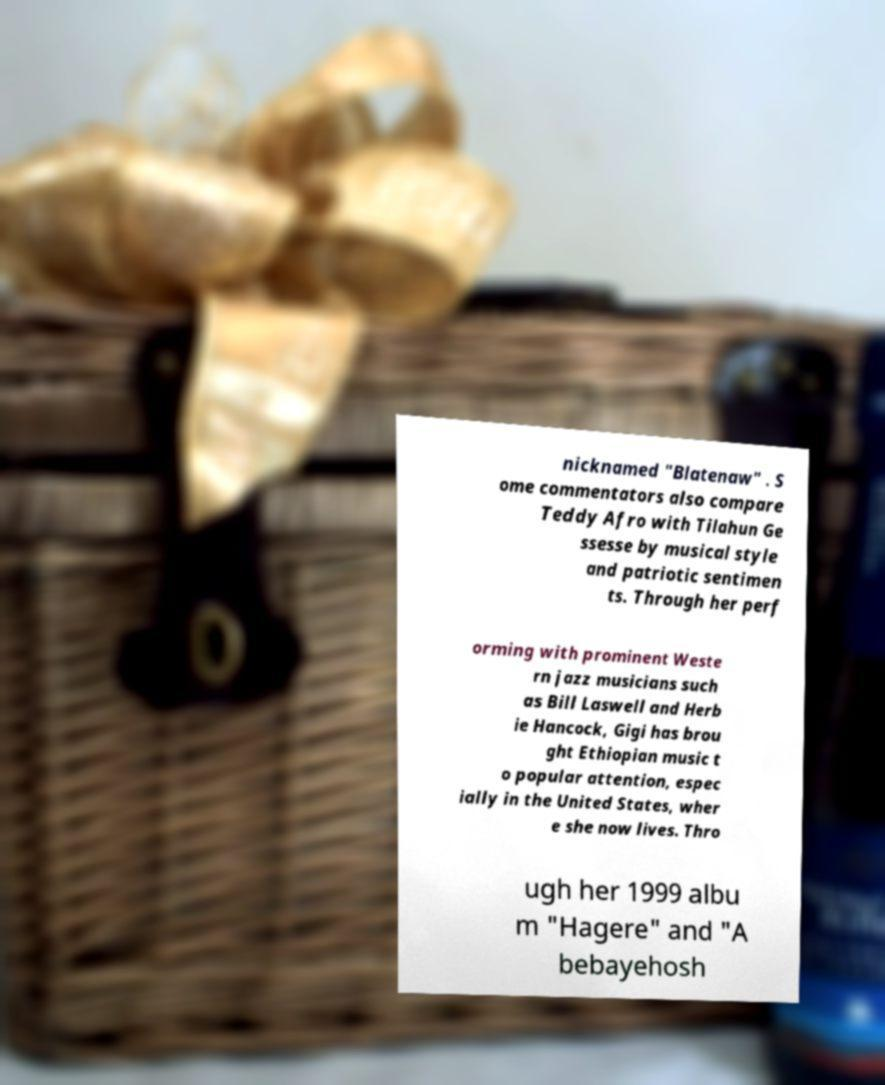For documentation purposes, I need the text within this image transcribed. Could you provide that? nicknamed "Blatenaw" . S ome commentators also compare Teddy Afro with Tilahun Ge ssesse by musical style and patriotic sentimen ts. Through her perf orming with prominent Weste rn jazz musicians such as Bill Laswell and Herb ie Hancock, Gigi has brou ght Ethiopian music t o popular attention, espec ially in the United States, wher e she now lives. Thro ugh her 1999 albu m "Hagere" and "A bebayehosh 